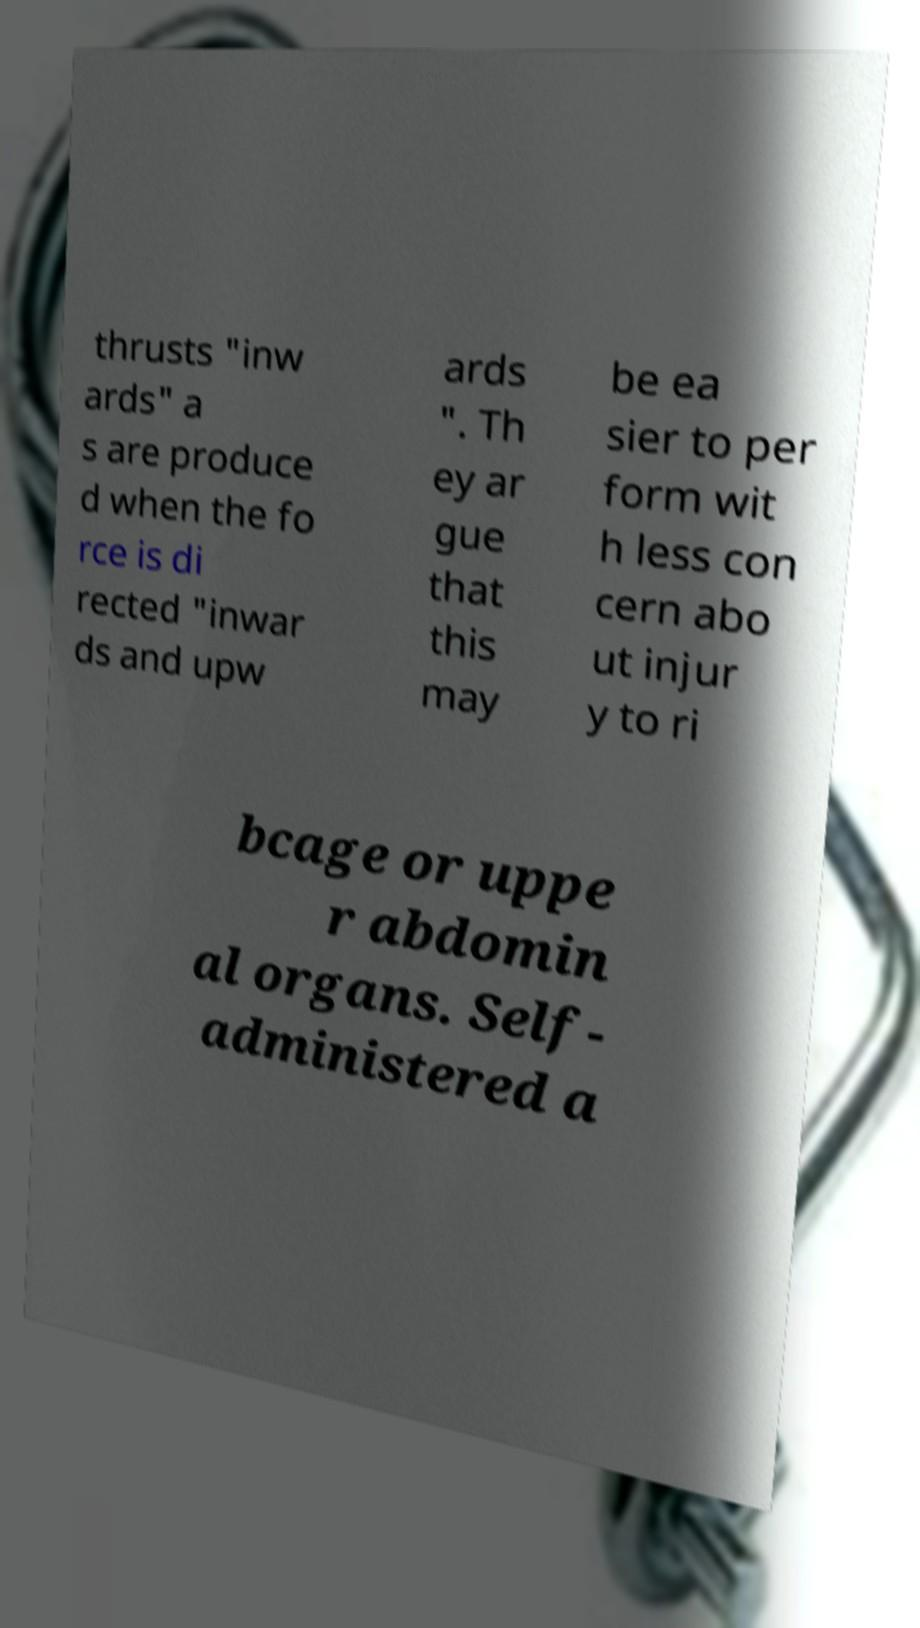What messages or text are displayed in this image? I need them in a readable, typed format. thrusts "inw ards" a s are produce d when the fo rce is di rected "inwar ds and upw ards ". Th ey ar gue that this may be ea sier to per form wit h less con cern abo ut injur y to ri bcage or uppe r abdomin al organs. Self- administered a 